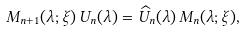Convert formula to latex. <formula><loc_0><loc_0><loc_500><loc_500>M _ { n + 1 } ( \lambda ; \xi ) \, U _ { n } ( \lambda ) = \widehat { U } _ { n } ( \lambda ) \, M _ { n } ( \lambda ; \xi ) ,</formula> 